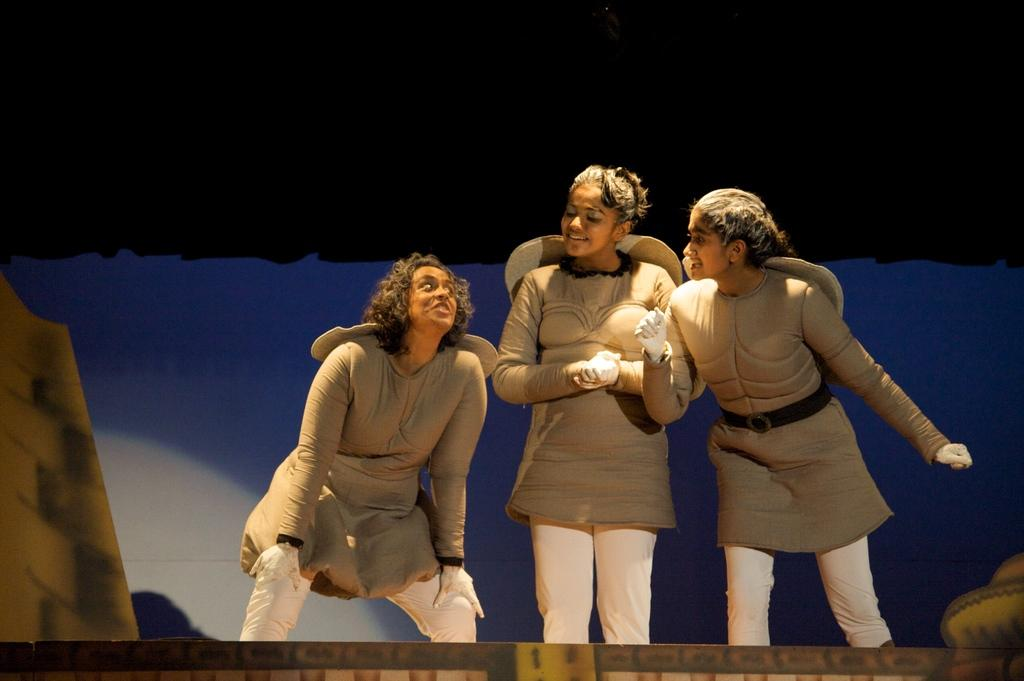How many women are in the image? There are three women in the image. What are the women wearing? The women are wearing fancy dresses. What are the women doing in the image? The women are standing. What can be seen at the bottom left and right sides of the image? There are objects at the bottom left and right sides of the image. What is visible in the background of the image? There is a board in the background of the image. What flavor of ice cream is the servant holding in the image? There is no servant or ice cream present in the image. How does the expansion of the board affect the women in the image? The image does not show any expansion of the board, and therefore it does not affect the women in the image. 